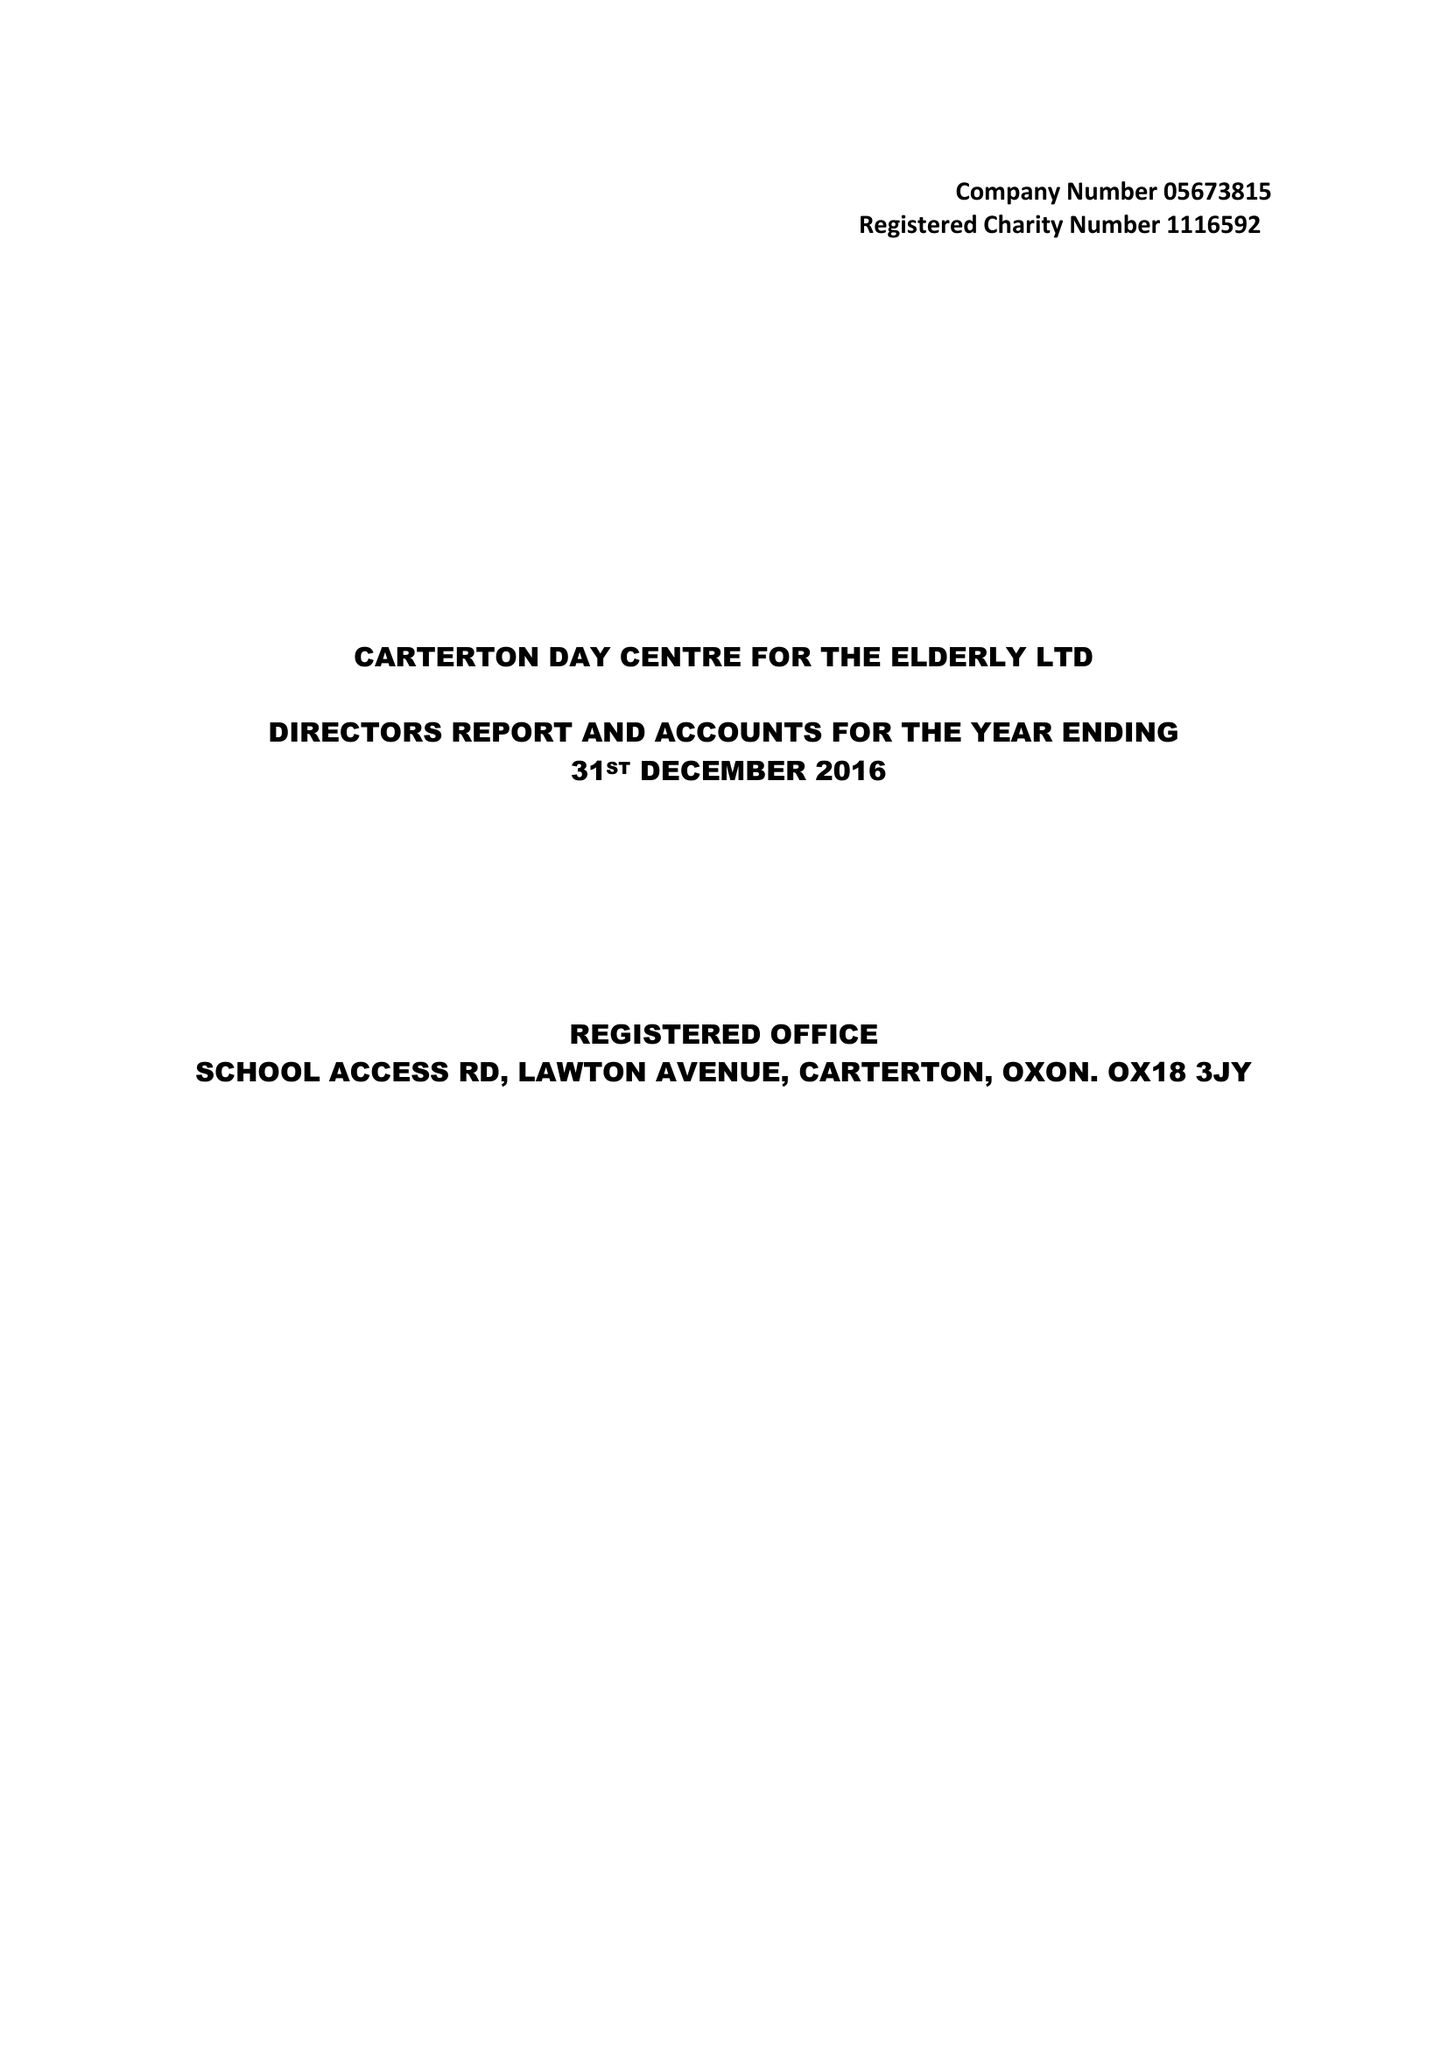What is the value for the income_annually_in_british_pounds?
Answer the question using a single word or phrase. 37844.00 